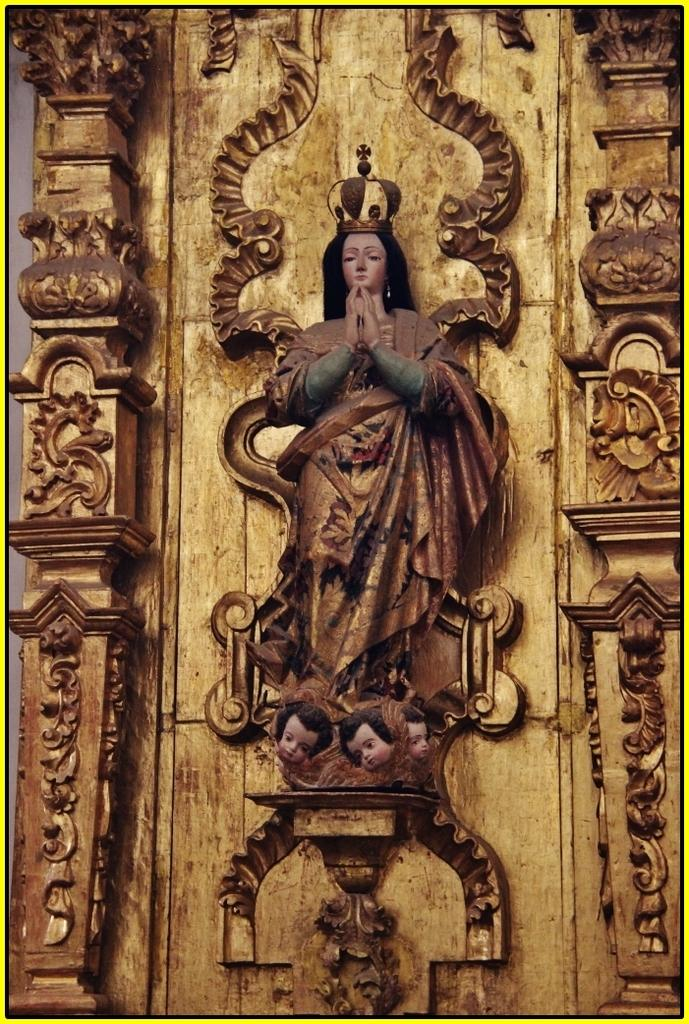What is depicted on the wall in the image? There is a statue on the wall in the image. What can be seen on the pillars in the image? There are sculptures on pillars in the image. What is the name of the person who desires the sculptures in the image? There is no information about anyone's desires or names in the image. The image only shows a statue on the wall and sculptures on pillars. 